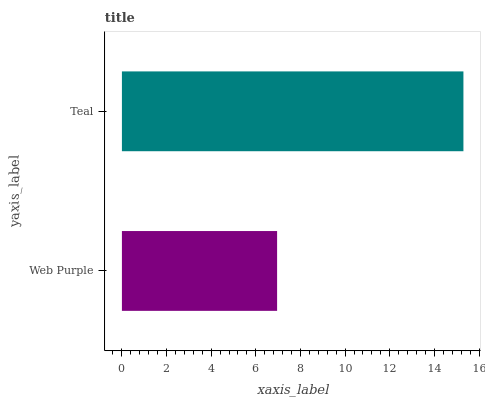Is Web Purple the minimum?
Answer yes or no. Yes. Is Teal the maximum?
Answer yes or no. Yes. Is Teal the minimum?
Answer yes or no. No. Is Teal greater than Web Purple?
Answer yes or no. Yes. Is Web Purple less than Teal?
Answer yes or no. Yes. Is Web Purple greater than Teal?
Answer yes or no. No. Is Teal less than Web Purple?
Answer yes or no. No. Is Teal the high median?
Answer yes or no. Yes. Is Web Purple the low median?
Answer yes or no. Yes. Is Web Purple the high median?
Answer yes or no. No. Is Teal the low median?
Answer yes or no. No. 